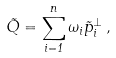Convert formula to latex. <formula><loc_0><loc_0><loc_500><loc_500>\vec { Q } = \sum _ { i = 1 } ^ { n } \omega _ { i } \vec { p } _ { i } ^ { \perp } \, ,</formula> 